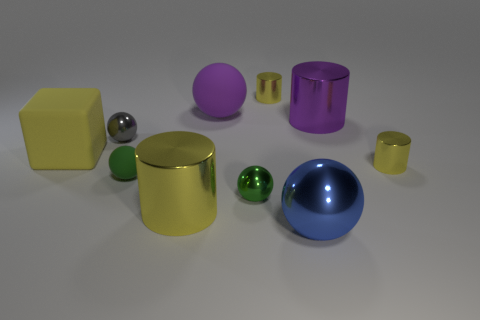There is a blue thing that is the same shape as the small gray metal thing; what is its material?
Keep it short and to the point. Metal. There is a object that is behind the purple rubber ball; does it have the same shape as the small gray metal object?
Provide a short and direct response. No. How many spheres are both right of the small green rubber sphere and left of the big metallic sphere?
Your response must be concise. 2. What number of purple matte things have the same shape as the yellow matte thing?
Offer a terse response. 0. There is a big sphere left of the green ball on the right side of the green rubber ball; what is its color?
Provide a short and direct response. Purple. Do the large purple matte thing and the blue metal object that is in front of the purple metal cylinder have the same shape?
Offer a very short reply. Yes. There is a big ball that is in front of the big purple cylinder behind the tiny yellow object in front of the gray shiny ball; what is it made of?
Your answer should be very brief. Metal. Are there any yellow cylinders of the same size as the matte block?
Keep it short and to the point. Yes. There is a green thing that is the same material as the purple sphere; what size is it?
Give a very brief answer. Small. What is the shape of the small green rubber thing?
Keep it short and to the point. Sphere. 